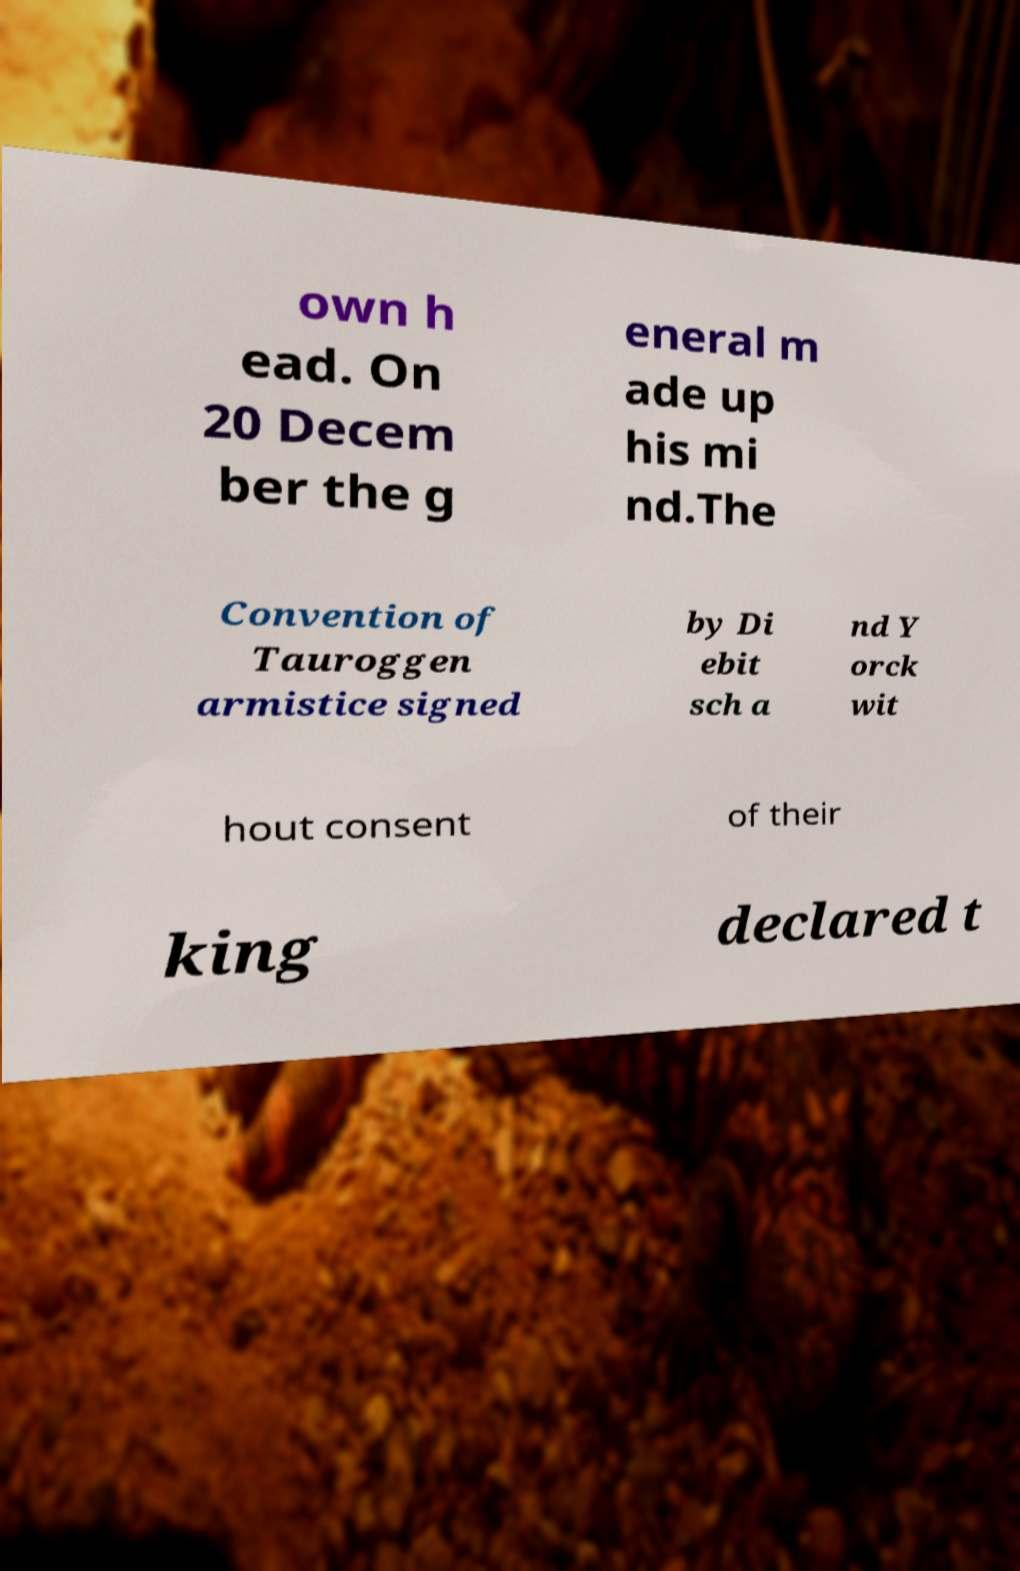Please identify and transcribe the text found in this image. own h ead. On 20 Decem ber the g eneral m ade up his mi nd.The Convention of Tauroggen armistice signed by Di ebit sch a nd Y orck wit hout consent of their king declared t 